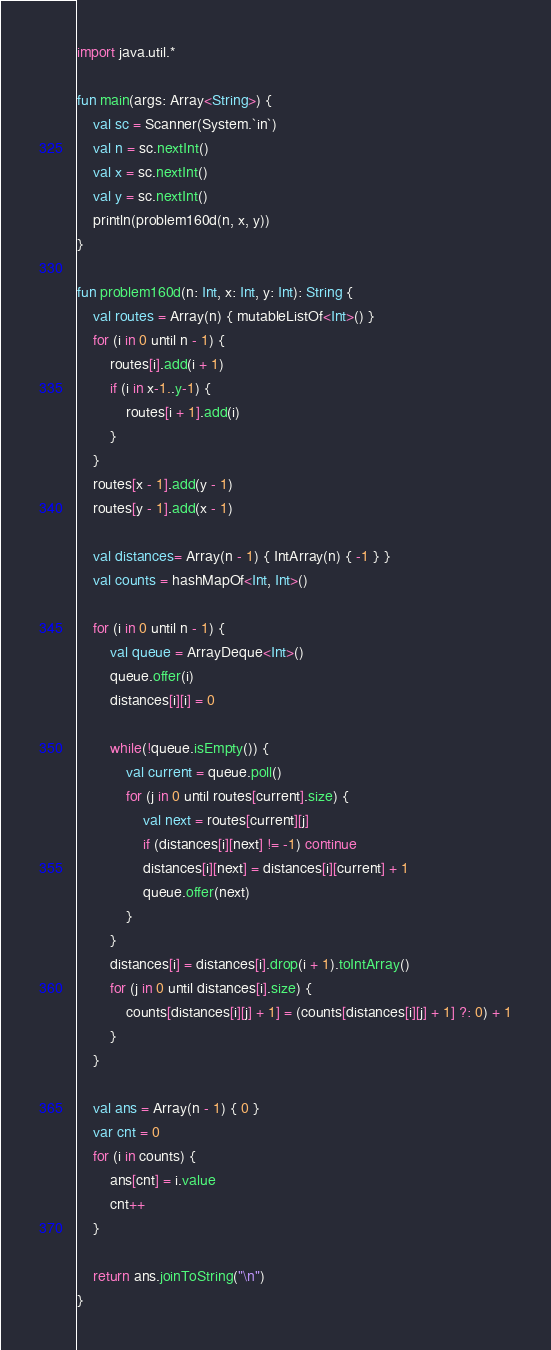<code> <loc_0><loc_0><loc_500><loc_500><_Kotlin_>import java.util.*

fun main(args: Array<String>) {
    val sc = Scanner(System.`in`)
    val n = sc.nextInt()
    val x = sc.nextInt()
    val y = sc.nextInt()
    println(problem160d(n, x, y))
}

fun problem160d(n: Int, x: Int, y: Int): String {
    val routes = Array(n) { mutableListOf<Int>() }
    for (i in 0 until n - 1) {
        routes[i].add(i + 1)
        if (i in x-1..y-1) {
            routes[i + 1].add(i)
        }
    }
    routes[x - 1].add(y - 1)
    routes[y - 1].add(x - 1)

    val distances= Array(n - 1) { IntArray(n) { -1 } }
    val counts = hashMapOf<Int, Int>()

    for (i in 0 until n - 1) {
        val queue = ArrayDeque<Int>()
        queue.offer(i)
        distances[i][i] = 0

        while(!queue.isEmpty()) {
            val current = queue.poll()
            for (j in 0 until routes[current].size) {
                val next = routes[current][j]
                if (distances[i][next] != -1) continue
                distances[i][next] = distances[i][current] + 1
                queue.offer(next)
            }
        }
        distances[i] = distances[i].drop(i + 1).toIntArray()
        for (j in 0 until distances[i].size) {
            counts[distances[i][j] + 1] = (counts[distances[i][j] + 1] ?: 0) + 1
        }
    }

    val ans = Array(n - 1) { 0 }
    var cnt = 0
    for (i in counts) {
        ans[cnt] = i.value
        cnt++
    }

    return ans.joinToString("\n")
}</code> 